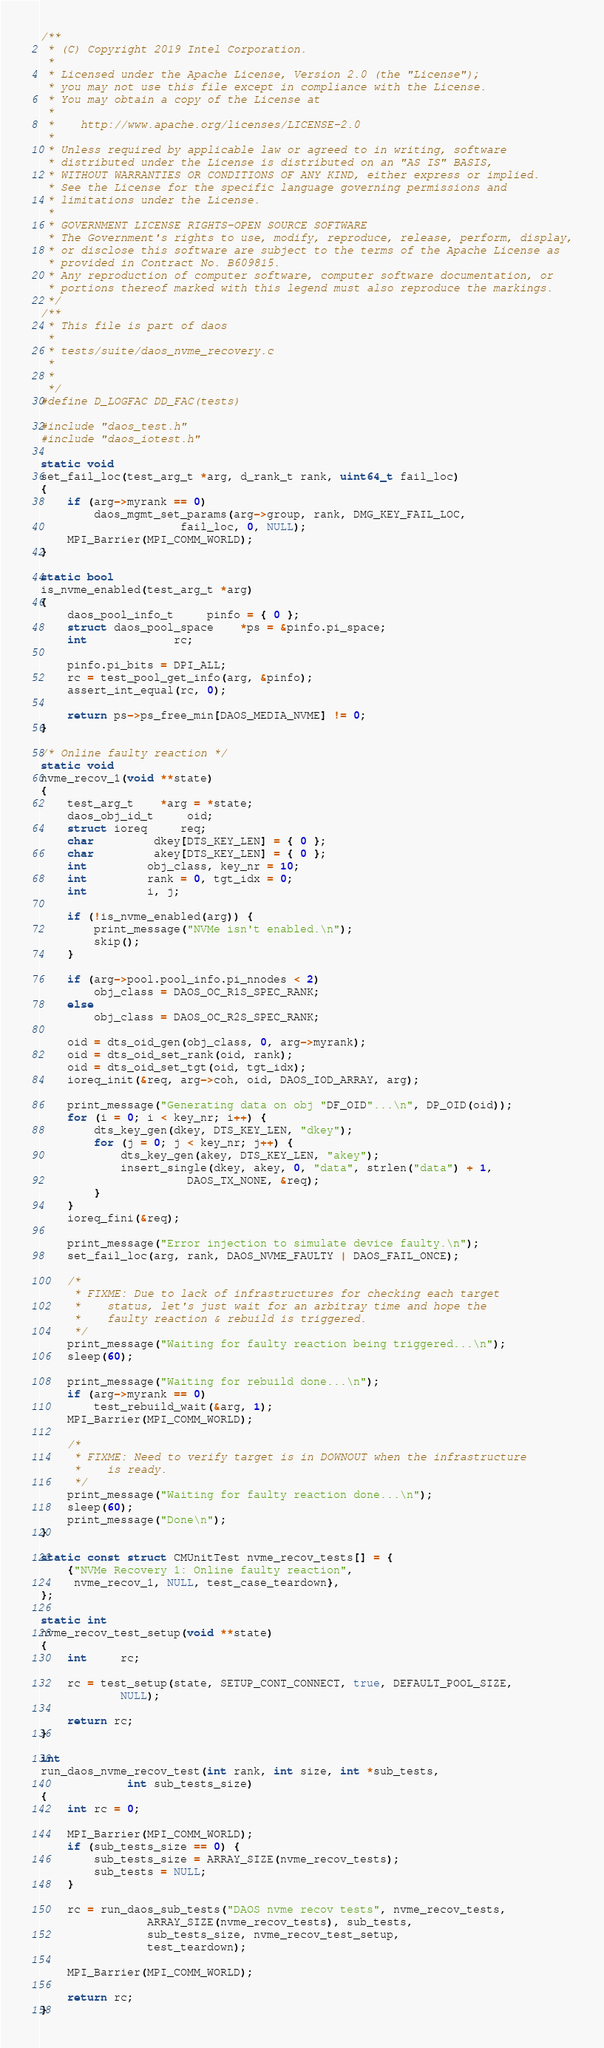<code> <loc_0><loc_0><loc_500><loc_500><_C_>/**
 * (C) Copyright 2019 Intel Corporation.
 *
 * Licensed under the Apache License, Version 2.0 (the "License");
 * you may not use this file except in compliance with the License.
 * You may obtain a copy of the License at
 *
 *    http://www.apache.org/licenses/LICENSE-2.0
 *
 * Unless required by applicable law or agreed to in writing, software
 * distributed under the License is distributed on an "AS IS" BASIS,
 * WITHOUT WARRANTIES OR CONDITIONS OF ANY KIND, either express or implied.
 * See the License for the specific language governing permissions and
 * limitations under the License.
 *
 * GOVERNMENT LICENSE RIGHTS-OPEN SOURCE SOFTWARE
 * The Government's rights to use, modify, reproduce, release, perform, display,
 * or disclose this software are subject to the terms of the Apache License as
 * provided in Contract No. B609815.
 * Any reproduction of computer software, computer software documentation, or
 * portions thereof marked with this legend must also reproduce the markings.
 */
/**
 * This file is part of daos
 *
 * tests/suite/daos_nvme_recovery.c
 *
 *
 */
#define D_LOGFAC	DD_FAC(tests)

#include "daos_test.h"
#include "daos_iotest.h"

static void
set_fail_loc(test_arg_t *arg, d_rank_t rank, uint64_t fail_loc)
{
	if (arg->myrank == 0)
		daos_mgmt_set_params(arg->group, rank, DMG_KEY_FAIL_LOC,
				     fail_loc, 0, NULL);
	MPI_Barrier(MPI_COMM_WORLD);
}

static bool
is_nvme_enabled(test_arg_t *arg)
{
	daos_pool_info_t	 pinfo = { 0 };
	struct daos_pool_space	*ps = &pinfo.pi_space;
	int			 rc;

	pinfo.pi_bits = DPI_ALL;
	rc = test_pool_get_info(arg, &pinfo);
	assert_int_equal(rc, 0);

	return ps->ps_free_min[DAOS_MEDIA_NVME] != 0;
}

/* Online faulty reaction */
static void
nvme_recov_1(void **state)
{
	test_arg_t	*arg = *state;
	daos_obj_id_t	 oid;
	struct ioreq	 req;
	char		 dkey[DTS_KEY_LEN] = { 0 };
	char		 akey[DTS_KEY_LEN] = { 0 };
	int		 obj_class, key_nr = 10;
	int		 rank = 0, tgt_idx = 0;
	int		 i, j;

	if (!is_nvme_enabled(arg)) {
		print_message("NVMe isn't enabled.\n");
		skip();
	}

	if (arg->pool.pool_info.pi_nnodes < 2)
		obj_class = DAOS_OC_R1S_SPEC_RANK;
	else
		obj_class = DAOS_OC_R2S_SPEC_RANK;

	oid = dts_oid_gen(obj_class, 0, arg->myrank);
	oid = dts_oid_set_rank(oid, rank);
	oid = dts_oid_set_tgt(oid, tgt_idx);
	ioreq_init(&req, arg->coh, oid, DAOS_IOD_ARRAY, arg);

	print_message("Generating data on obj "DF_OID"...\n", DP_OID(oid));
	for (i = 0; i < key_nr; i++) {
		dts_key_gen(dkey, DTS_KEY_LEN, "dkey");
		for (j = 0; j < key_nr; j++) {
			dts_key_gen(akey, DTS_KEY_LEN, "akey");
			insert_single(dkey, akey, 0, "data", strlen("data") + 1,
				      DAOS_TX_NONE, &req);
		}
	}
	ioreq_fini(&req);

	print_message("Error injection to simulate device faulty.\n");
	set_fail_loc(arg, rank, DAOS_NVME_FAULTY | DAOS_FAIL_ONCE);

	/*
	 * FIXME: Due to lack of infrastructures for checking each target
	 *	  status, let's just wait for an arbitray time and hope the
	 *	  faulty reaction & rebuild is triggered.
	 */
	print_message("Waiting for faulty reaction being triggered...\n");
	sleep(60);

	print_message("Waiting for rebuild done...\n");
	if (arg->myrank == 0)
		test_rebuild_wait(&arg, 1);
	MPI_Barrier(MPI_COMM_WORLD);

	/*
	 * FIXME: Need to verify target is in DOWNOUT when the infrastructure
	 *	  is ready.
	 */
	print_message("Waiting for faulty reaction done...\n");
	sleep(60);
	print_message("Done\n");
}

static const struct CMUnitTest nvme_recov_tests[] = {
	{"NVMe Recovery 1: Online faulty reaction",
	 nvme_recov_1, NULL, test_case_teardown},
};

static int
nvme_recov_test_setup(void **state)
{
	int     rc;

	rc = test_setup(state, SETUP_CONT_CONNECT, true, DEFAULT_POOL_SIZE,
			NULL);

	return rc;
}

int
run_daos_nvme_recov_test(int rank, int size, int *sub_tests,
			 int sub_tests_size)
{
	int rc = 0;

	MPI_Barrier(MPI_COMM_WORLD);
	if (sub_tests_size == 0) {
		sub_tests_size = ARRAY_SIZE(nvme_recov_tests);
		sub_tests = NULL;
	}

	rc = run_daos_sub_tests("DAOS nvme recov tests", nvme_recov_tests,
				ARRAY_SIZE(nvme_recov_tests), sub_tests,
				sub_tests_size, nvme_recov_test_setup,
				test_teardown);

	MPI_Barrier(MPI_COMM_WORLD);

	return rc;
}
</code> 